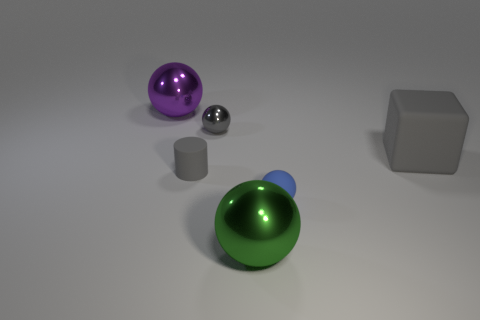Is there a green shiny ball that is in front of the big metal object in front of the big purple shiny ball? no 